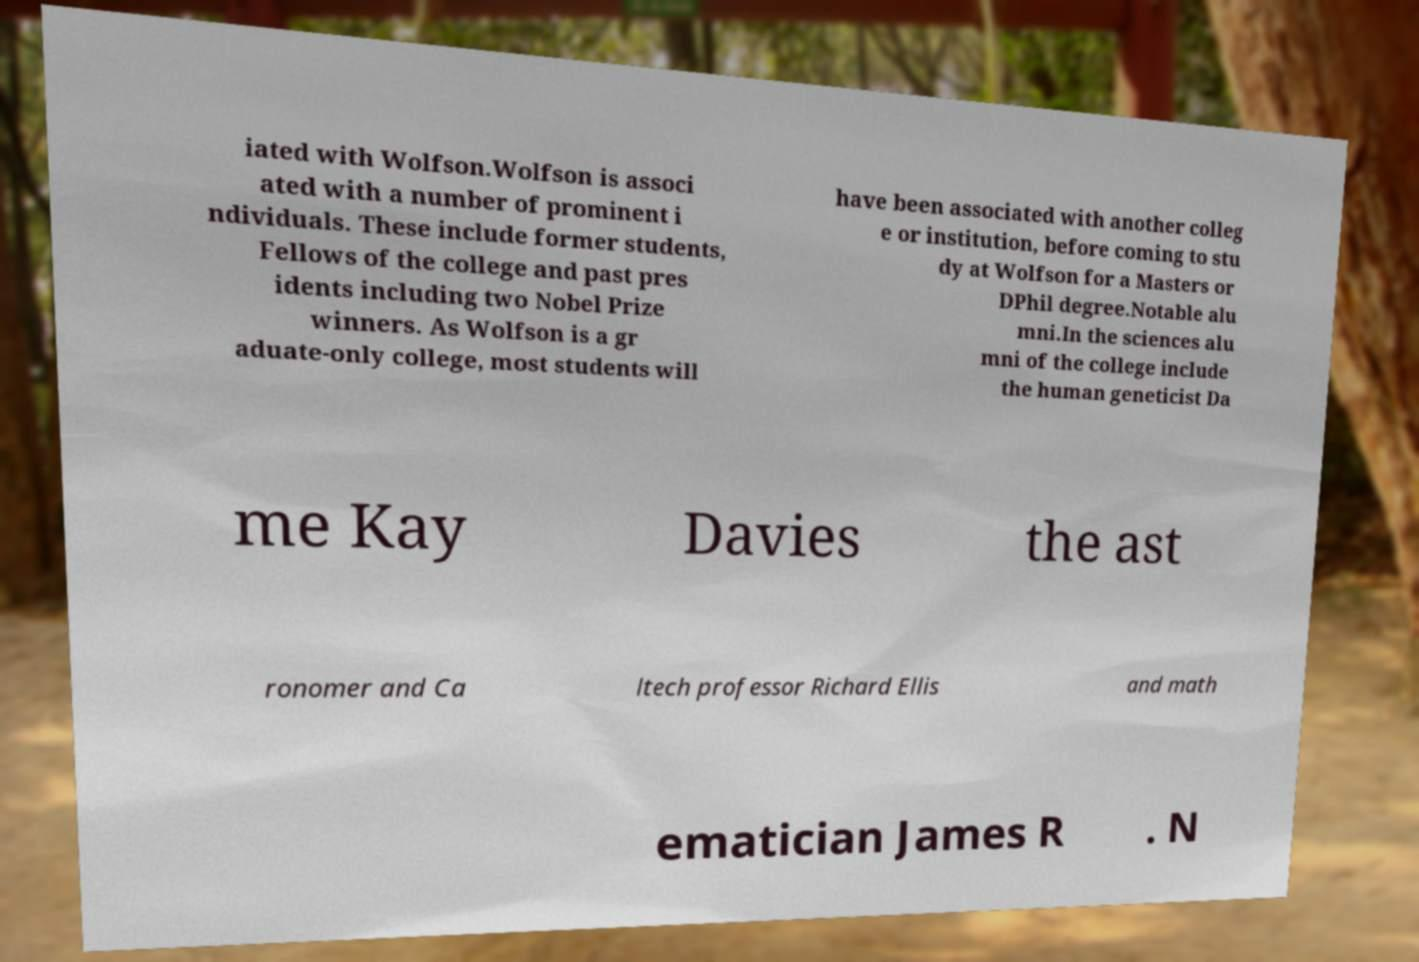Can you read and provide the text displayed in the image?This photo seems to have some interesting text. Can you extract and type it out for me? iated with Wolfson.Wolfson is associ ated with a number of prominent i ndividuals. These include former students, Fellows of the college and past pres idents including two Nobel Prize winners. As Wolfson is a gr aduate-only college, most students will have been associated with another colleg e or institution, before coming to stu dy at Wolfson for a Masters or DPhil degree.Notable alu mni.In the sciences alu mni of the college include the human geneticist Da me Kay Davies the ast ronomer and Ca ltech professor Richard Ellis and math ematician James R . N 